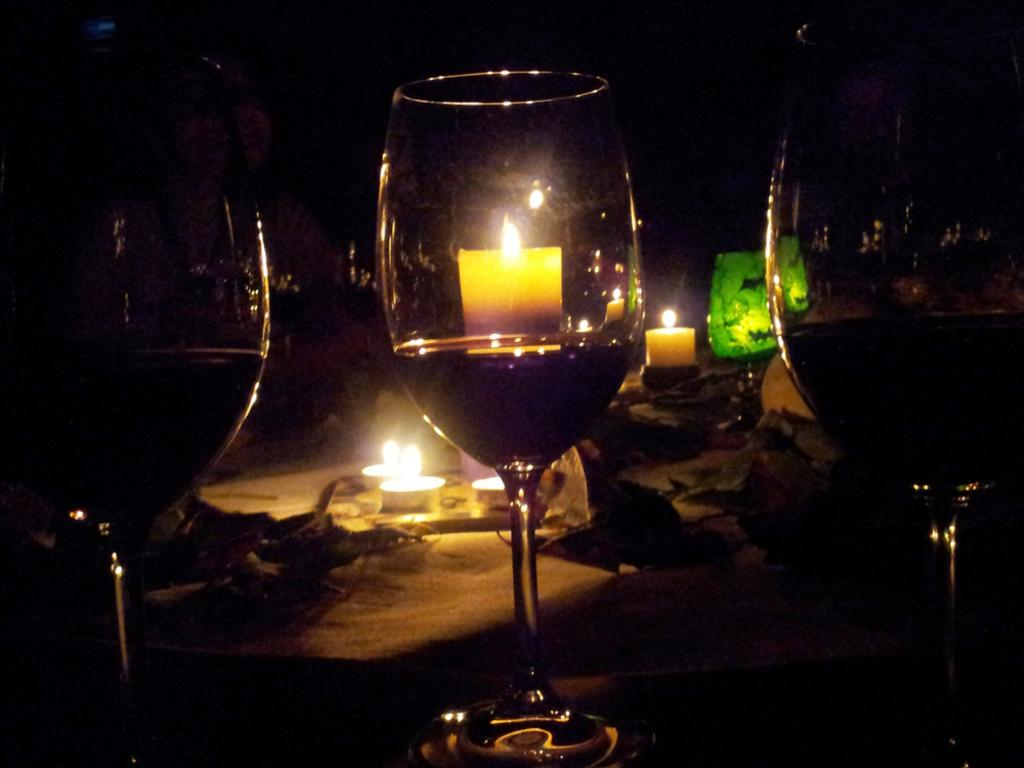What type of objects can be seen in the image? There are glasses and candles in the image. Are there any other objects present in the image? Yes, there are other objects placed on a surface in the image. What type of tail can be seen on the ornament in the image? There is no ornament with a tail present in the image. What show is being performed on the surface in the image? There is no show being performed in the image; it only features glasses, candles, and other objects placed on a surface. 